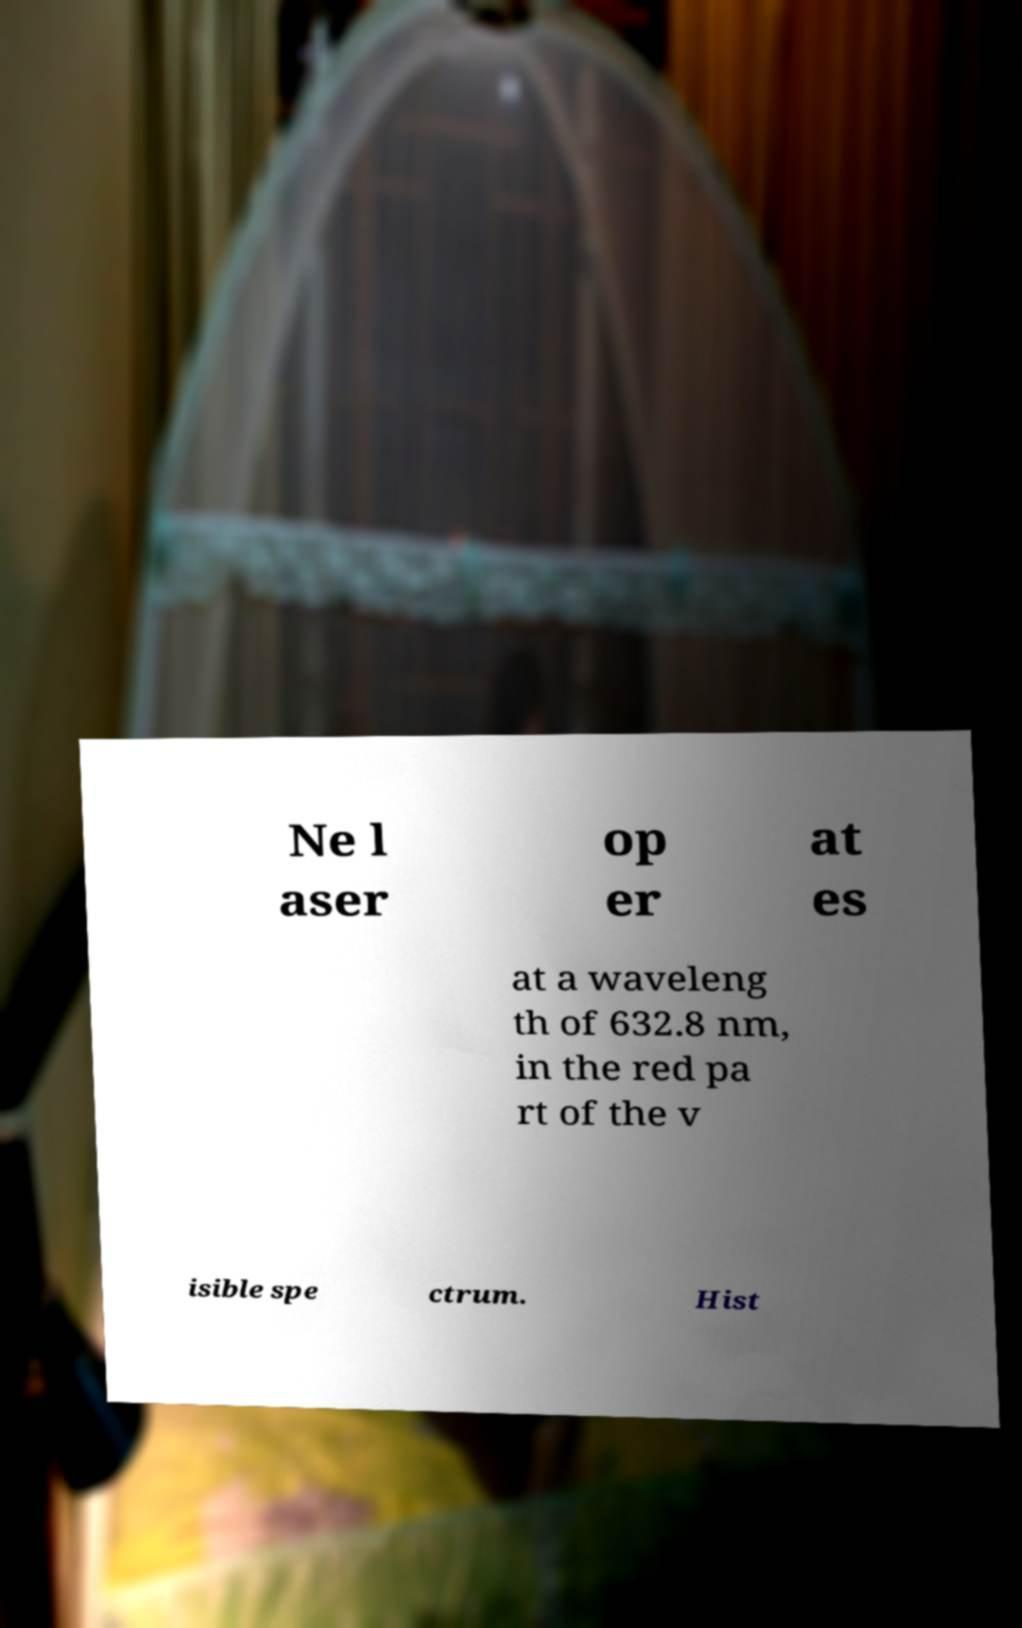Could you assist in decoding the text presented in this image and type it out clearly? Ne l aser op er at es at a waveleng th of 632.8 nm, in the red pa rt of the v isible spe ctrum. Hist 